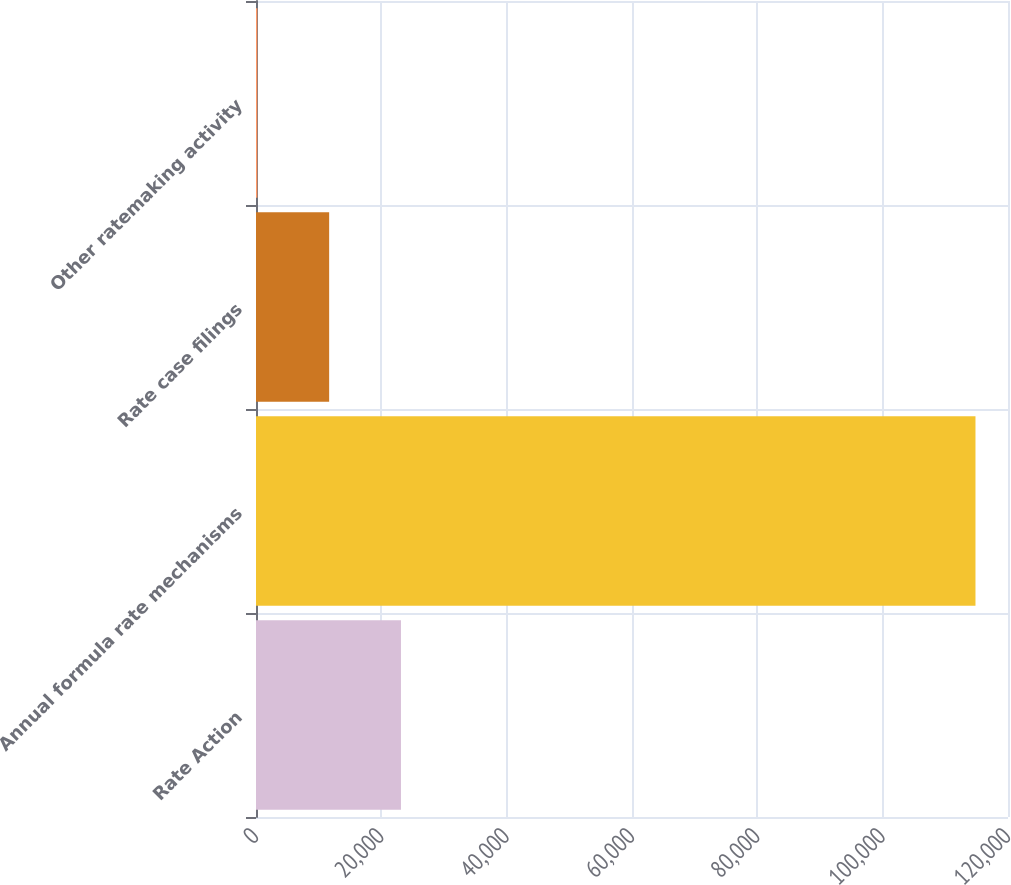Convert chart to OTSL. <chart><loc_0><loc_0><loc_500><loc_500><bar_chart><fcel>Rate Action<fcel>Annual formula rate mechanisms<fcel>Rate case filings<fcel>Other ratemaking activity<nl><fcel>23133.2<fcel>114810<fcel>11673.6<fcel>214<nl></chart> 